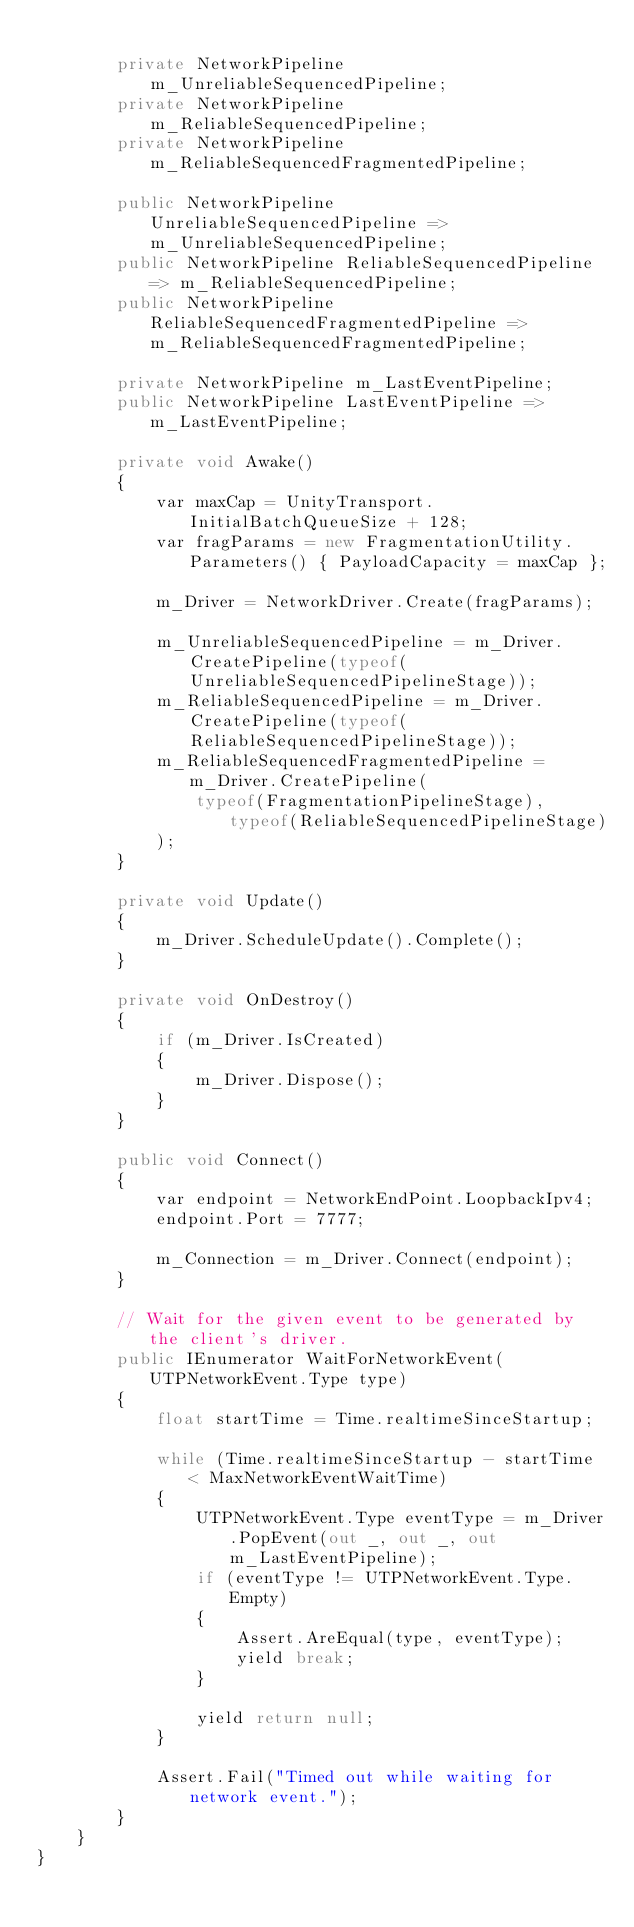Convert code to text. <code><loc_0><loc_0><loc_500><loc_500><_C#_>
        private NetworkPipeline m_UnreliableSequencedPipeline;
        private NetworkPipeline m_ReliableSequencedPipeline;
        private NetworkPipeline m_ReliableSequencedFragmentedPipeline;

        public NetworkPipeline UnreliableSequencedPipeline => m_UnreliableSequencedPipeline;
        public NetworkPipeline ReliableSequencedPipeline => m_ReliableSequencedPipeline;
        public NetworkPipeline ReliableSequencedFragmentedPipeline => m_ReliableSequencedFragmentedPipeline;

        private NetworkPipeline m_LastEventPipeline;
        public NetworkPipeline LastEventPipeline => m_LastEventPipeline;

        private void Awake()
        {
            var maxCap = UnityTransport.InitialBatchQueueSize + 128;
            var fragParams = new FragmentationUtility.Parameters() { PayloadCapacity = maxCap };

            m_Driver = NetworkDriver.Create(fragParams);

            m_UnreliableSequencedPipeline = m_Driver.CreatePipeline(typeof(UnreliableSequencedPipelineStage));
            m_ReliableSequencedPipeline = m_Driver.CreatePipeline(typeof(ReliableSequencedPipelineStage));
            m_ReliableSequencedFragmentedPipeline = m_Driver.CreatePipeline(
                typeof(FragmentationPipelineStage), typeof(ReliableSequencedPipelineStage)
            );
        }

        private void Update()
        {
            m_Driver.ScheduleUpdate().Complete();
        }

        private void OnDestroy()
        {
            if (m_Driver.IsCreated)
            {
                m_Driver.Dispose();
            }
        }

        public void Connect()
        {
            var endpoint = NetworkEndPoint.LoopbackIpv4;
            endpoint.Port = 7777;

            m_Connection = m_Driver.Connect(endpoint);
        }

        // Wait for the given event to be generated by the client's driver.
        public IEnumerator WaitForNetworkEvent(UTPNetworkEvent.Type type)
        {
            float startTime = Time.realtimeSinceStartup;

            while (Time.realtimeSinceStartup - startTime < MaxNetworkEventWaitTime)
            {
                UTPNetworkEvent.Type eventType = m_Driver.PopEvent(out _, out _, out m_LastEventPipeline);
                if (eventType != UTPNetworkEvent.Type.Empty)
                {
                    Assert.AreEqual(type, eventType);
                    yield break;
                }

                yield return null;
            }

            Assert.Fail("Timed out while waiting for network event.");
        }
    }
}
</code> 